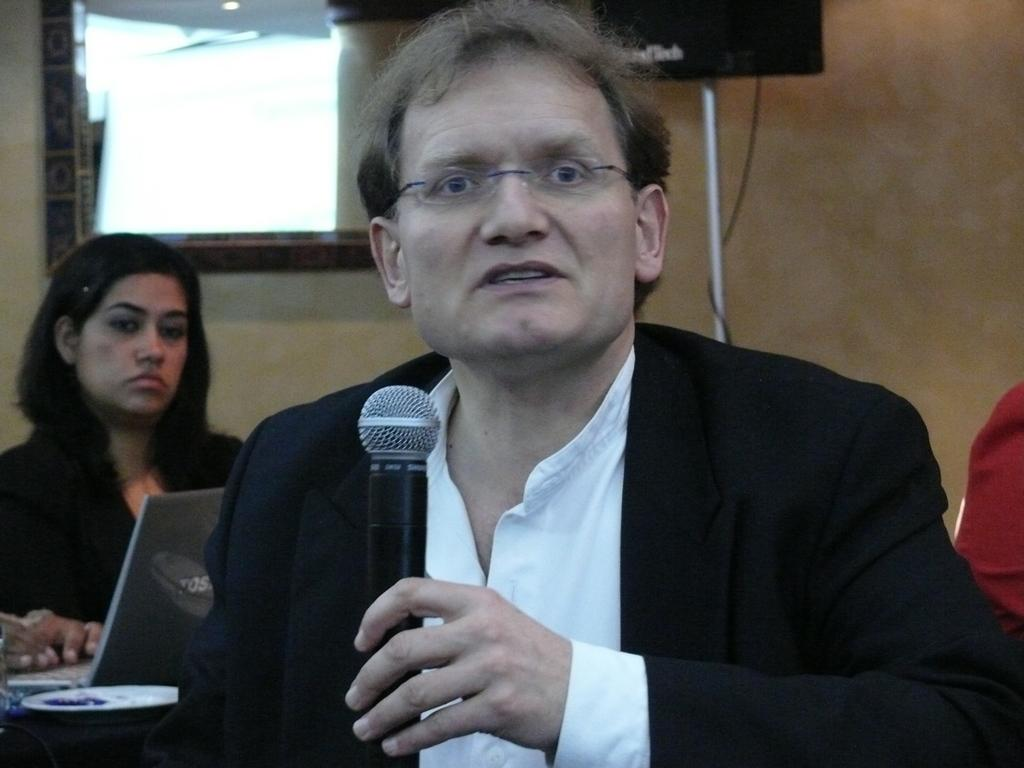Who is the main subject in the image? There is a man in the center of the image. What is the man doing in the image? The man is speaking on a microphone. Can you describe the woman in the image? There is a woman in the background of the image, and she is on the left side of the image. What are the man's hobbies, and how do they relate to the microphone in the image? The image does not provide information about the man's hobbies, nor does it show any connection between his hobbies and the microphone. 